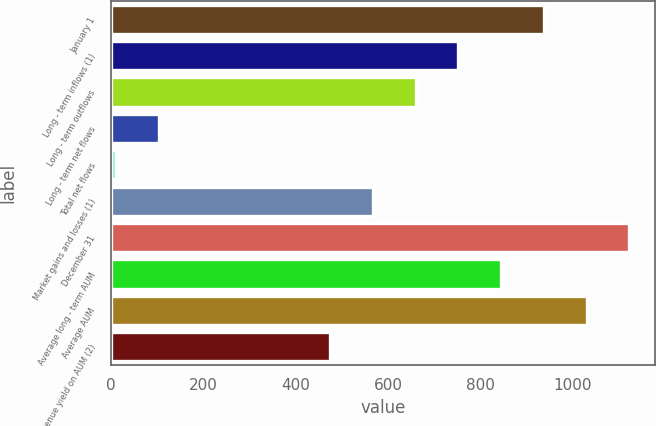<chart> <loc_0><loc_0><loc_500><loc_500><bar_chart><fcel>January 1<fcel>Long - term inflows (1)<fcel>Long - term outflows<fcel>Long - term net flows<fcel>Total net flows<fcel>Market gains and losses (1)<fcel>December 31<fcel>Average long - term AUM<fcel>Average AUM<fcel>Gross revenue yield on AUM (2)<nl><fcel>937.6<fcel>752.34<fcel>659.71<fcel>103.93<fcel>11.3<fcel>567.08<fcel>1122.86<fcel>844.97<fcel>1030.23<fcel>474.45<nl></chart> 